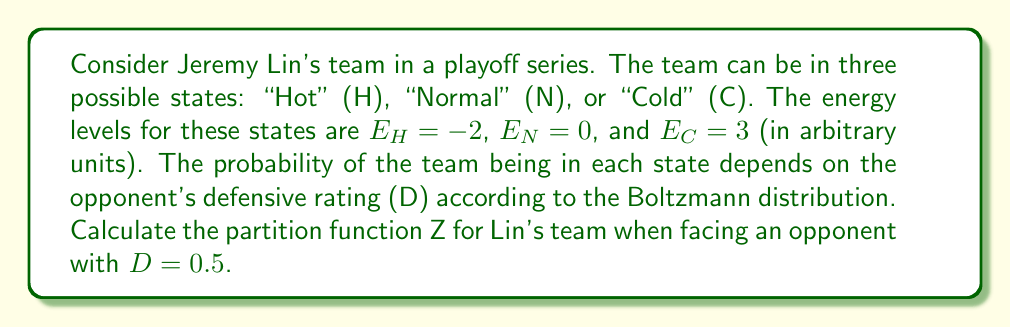Can you answer this question? To solve this problem, we'll follow these steps:

1) Recall the formula for the partition function:
   $$Z = \sum_i e^{-\beta E_i}$$
   where $\beta = \frac{1}{k_BT}$, but in this case, we'll use D (defensive rating) instead of T.

2) In our case, $\beta = D = 0.5$, and we have three states (H, N, C) with their respective energies.

3) Let's calculate the contribution of each state to the partition function:

   For Hot (H) state: 
   $$e^{-0.5 \cdot (-2)} = e^1 = 2.71828$$

   For Normal (N) state:
   $$e^{-0.5 \cdot 0} = e^0 = 1$$

   For Cold (C) state:
   $$e^{-0.5 \cdot 3} = e^{-1.5} = 0.22313$$

4) Now, we sum these values to get Z:
   $$Z = 2.71828 + 1 + 0.22313 = 3.94141$$

5) Rounding to four decimal places:
   $$Z \approx 3.9414$$
Answer: 3.9414 